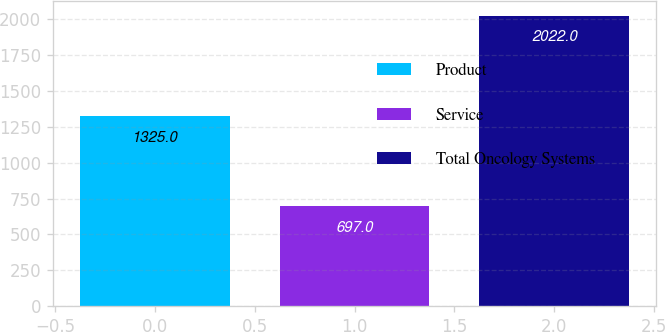Convert chart to OTSL. <chart><loc_0><loc_0><loc_500><loc_500><bar_chart><fcel>Product<fcel>Service<fcel>Total Oncology Systems<nl><fcel>1325<fcel>697<fcel>2022<nl></chart> 